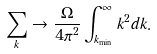Convert formula to latex. <formula><loc_0><loc_0><loc_500><loc_500>\sum _ { k } \rightarrow \frac { \Omega } { 4 \pi ^ { 2 } } \int ^ { \infty } _ { k _ { \min } } k ^ { 2 } d k .</formula> 